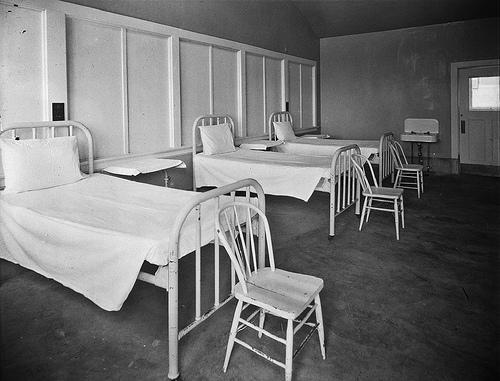How many beds are in the room?
Give a very brief answer. 3. How many beds can you see?
Give a very brief answer. 3. 